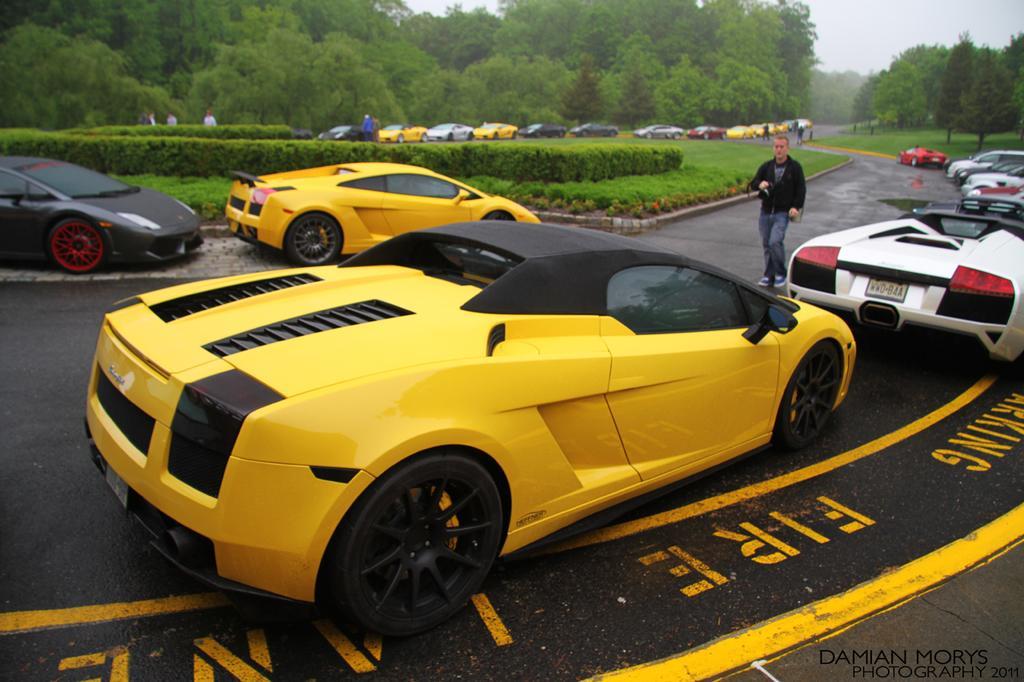Please provide a concise description of this image. In this image I can see a beautiful yellow color car on the road. On the right side a man is walking on the road. He wore black color coat, there are few other color cars on this road in the middle there are bushes at the back side there are trees. 